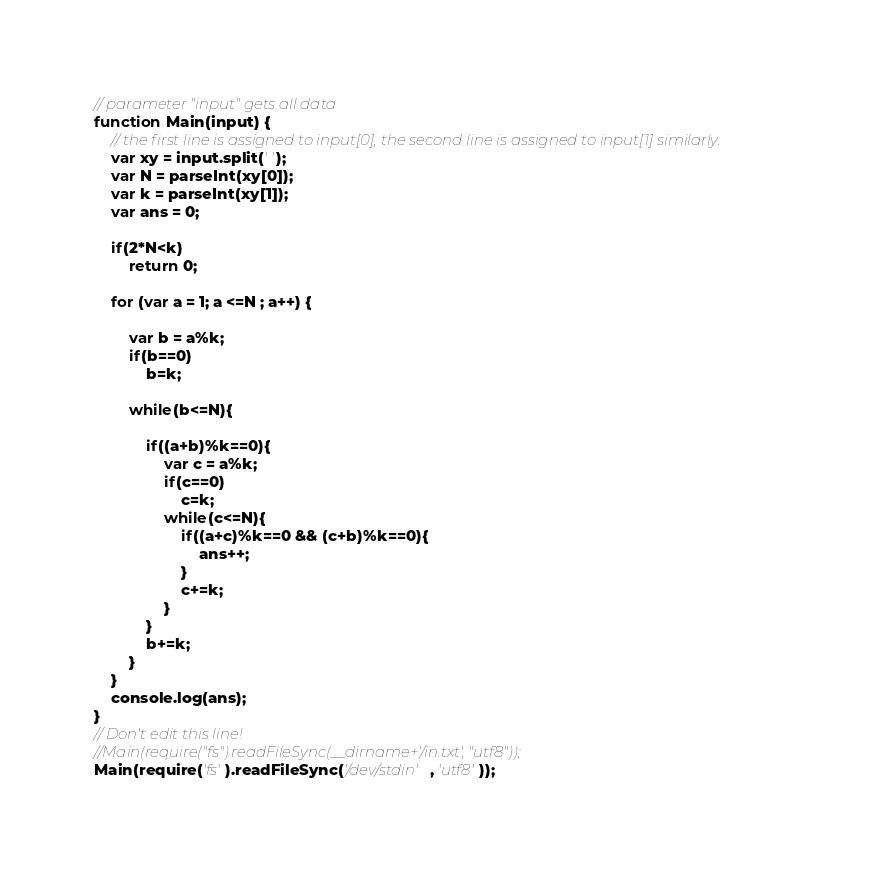<code> <loc_0><loc_0><loc_500><loc_500><_JavaScript_>// parameter "input" gets all data
function Main(input) {
	// the first line is assigned to input[0], the second line is assigned to input[1] similarly.
	var xy = input.split(' ');
	var N = parseInt(xy[0]);
	var k = parseInt(xy[1]);
	var ans = 0;

	if(2*N<k)
		return 0;

	for (var a = 1; a <=N ; a++) {

		var b = a%k;
		if(b==0)
			b=k;

		while(b<=N){

			if((a+b)%k==0){
				var c = a%k;
				if(c==0)
					c=k;
				while(c<=N){
					if((a+c)%k==0 && (c+b)%k==0){
						ans++;
					}
					c+=k;
				}
			}
			b+=k;		
		}	
	}
	console.log(ans);
}
// Don't edit this line!
//Main(require("fs").readFileSync(__dirname+'/in.txt', "utf8"));
Main(require('fs').readFileSync('/dev/stdin', 'utf8'));</code> 